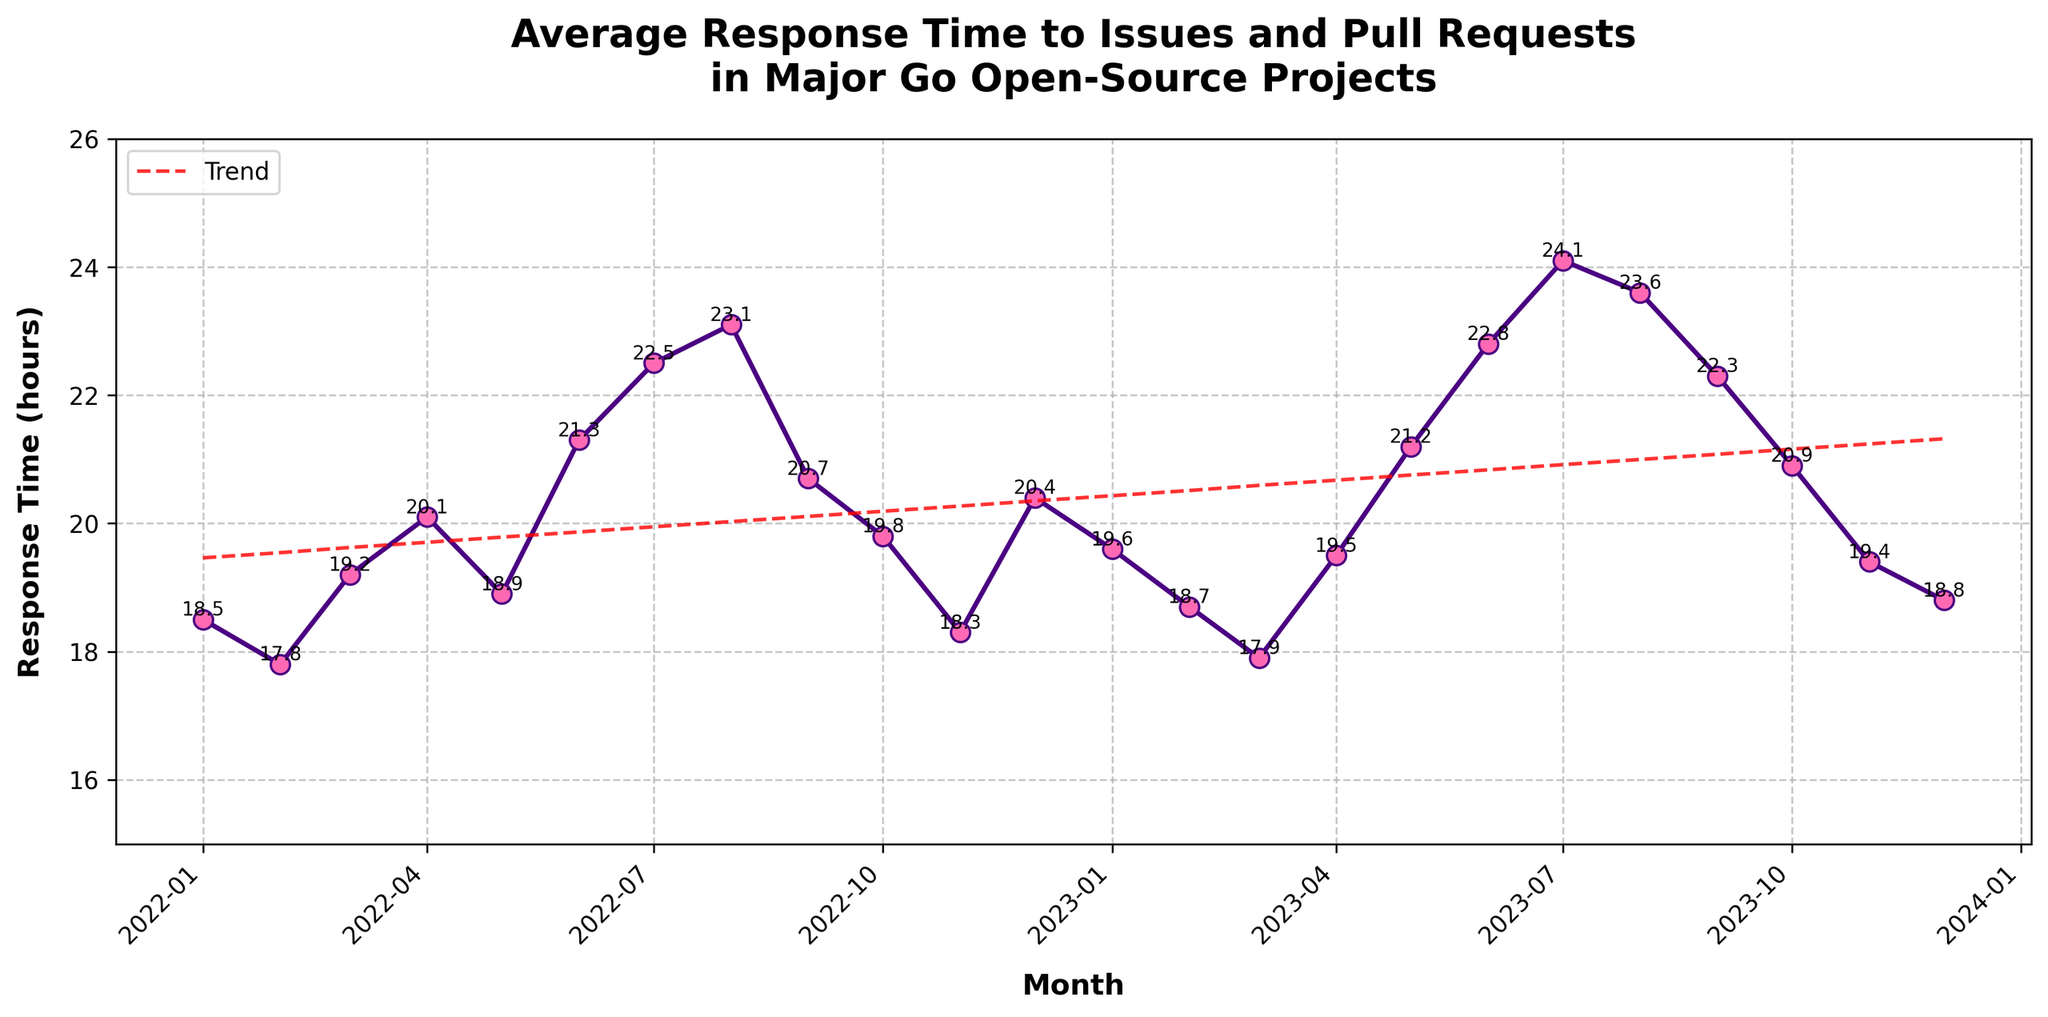What's the average response time for March 2022? On the line chart, locate the point for March 2022. The data label next to it indicates the response time.
Answer: 19.2 hours Between June 2022 and July 2023, in which month was the highest average response time observed? Identify the highest point on the chart between June 2022 and July 2023. The data label on this peak indicates the month and response time.
Answer: July 2023 Has the response time in December 2023 increased or decreased compared to January 2023? Compare the data points at December 2023 and January 2023. Check the values next to these points to determine the trend.
Answer: Decreased What is the overall trend in average response time across the two years, based on the trend line? Follow the red trend line from the start to the end of the graph. Identify whether it slopes upwards or downwards.
Answer: Upwards How many months recorded an average response time higher than 21 hours? Count the number of data points above the 21-hour mark.
Answer: 5 months What is the percentage increase in response time from February 2022 to July 2022? Calculate the increase by subtracting the February 2022 response time from the July 2022 response time. Then, divide the increase by the February 2022 response time and multiply by 100 for the percentage. \((22.5 - 17.8) / 17.8 * 100\)
Answer: 26.4% In which month was the average response time the lowest in 2023? Check all the data points in 2023 and identify the one with the lowest value.
Answer: March 2023 What is the difference between the highest response time and the lowest response time in the dataset? Identify the highest and lowest data points in the line chart. Subtract the lowest value from the highest value. \(24.1 - 17.8\)
Answer: 6.3 hours How does the response time in January 2023 compare to the response time in January 2022? Compare the data points for January 2023 and January 2022. Check the values to determine which is higher.
Answer: January 2023 is higher 